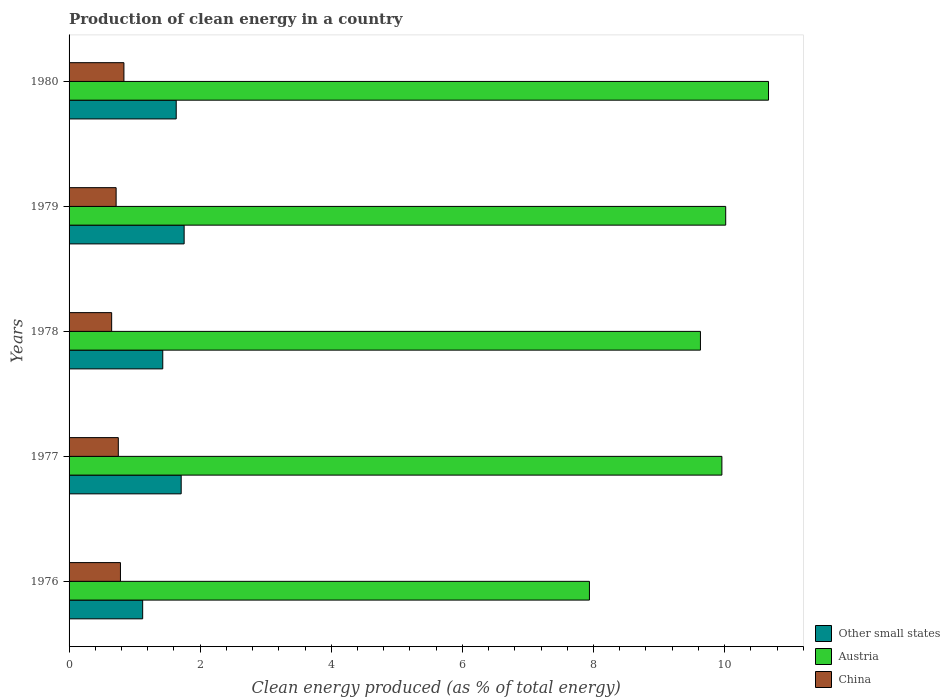How many different coloured bars are there?
Your answer should be very brief. 3. How many groups of bars are there?
Offer a terse response. 5. What is the label of the 1st group of bars from the top?
Ensure brevity in your answer.  1980. What is the percentage of clean energy produced in Other small states in 1977?
Make the answer very short. 1.71. Across all years, what is the maximum percentage of clean energy produced in Austria?
Make the answer very short. 10.67. Across all years, what is the minimum percentage of clean energy produced in China?
Your answer should be very brief. 0.65. In which year was the percentage of clean energy produced in Other small states minimum?
Make the answer very short. 1976. What is the total percentage of clean energy produced in Austria in the graph?
Give a very brief answer. 48.21. What is the difference between the percentage of clean energy produced in China in 1976 and that in 1980?
Make the answer very short. -0.05. What is the difference between the percentage of clean energy produced in Austria in 1980 and the percentage of clean energy produced in China in 1979?
Your answer should be compact. 9.95. What is the average percentage of clean energy produced in China per year?
Provide a succinct answer. 0.75. In the year 1977, what is the difference between the percentage of clean energy produced in Other small states and percentage of clean energy produced in Austria?
Offer a very short reply. -8.25. In how many years, is the percentage of clean energy produced in Austria greater than 4.4 %?
Ensure brevity in your answer.  5. What is the ratio of the percentage of clean energy produced in Other small states in 1979 to that in 1980?
Ensure brevity in your answer.  1.07. Is the percentage of clean energy produced in Austria in 1978 less than that in 1980?
Offer a very short reply. Yes. What is the difference between the highest and the second highest percentage of clean energy produced in China?
Provide a succinct answer. 0.05. What is the difference between the highest and the lowest percentage of clean energy produced in Other small states?
Give a very brief answer. 0.63. What does the 1st bar from the top in 1978 represents?
Provide a short and direct response. China. What does the 1st bar from the bottom in 1979 represents?
Offer a terse response. Other small states. Is it the case that in every year, the sum of the percentage of clean energy produced in China and percentage of clean energy produced in Austria is greater than the percentage of clean energy produced in Other small states?
Ensure brevity in your answer.  Yes. How many years are there in the graph?
Provide a short and direct response. 5. What is the difference between two consecutive major ticks on the X-axis?
Your answer should be very brief. 2. Does the graph contain grids?
Ensure brevity in your answer.  No. Where does the legend appear in the graph?
Your response must be concise. Bottom right. How many legend labels are there?
Ensure brevity in your answer.  3. How are the legend labels stacked?
Your answer should be very brief. Vertical. What is the title of the graph?
Keep it short and to the point. Production of clean energy in a country. What is the label or title of the X-axis?
Offer a terse response. Clean energy produced (as % of total energy). What is the Clean energy produced (as % of total energy) of Other small states in 1976?
Give a very brief answer. 1.12. What is the Clean energy produced (as % of total energy) in Austria in 1976?
Provide a short and direct response. 7.94. What is the Clean energy produced (as % of total energy) of China in 1976?
Provide a short and direct response. 0.78. What is the Clean energy produced (as % of total energy) of Other small states in 1977?
Give a very brief answer. 1.71. What is the Clean energy produced (as % of total energy) of Austria in 1977?
Your answer should be compact. 9.96. What is the Clean energy produced (as % of total energy) of China in 1977?
Your answer should be compact. 0.75. What is the Clean energy produced (as % of total energy) of Other small states in 1978?
Keep it short and to the point. 1.43. What is the Clean energy produced (as % of total energy) of Austria in 1978?
Your response must be concise. 9.63. What is the Clean energy produced (as % of total energy) in China in 1978?
Keep it short and to the point. 0.65. What is the Clean energy produced (as % of total energy) in Other small states in 1979?
Your response must be concise. 1.76. What is the Clean energy produced (as % of total energy) of Austria in 1979?
Offer a very short reply. 10.02. What is the Clean energy produced (as % of total energy) in China in 1979?
Provide a short and direct response. 0.72. What is the Clean energy produced (as % of total energy) of Other small states in 1980?
Offer a very short reply. 1.63. What is the Clean energy produced (as % of total energy) of Austria in 1980?
Your response must be concise. 10.67. What is the Clean energy produced (as % of total energy) of China in 1980?
Your response must be concise. 0.84. Across all years, what is the maximum Clean energy produced (as % of total energy) of Other small states?
Offer a terse response. 1.76. Across all years, what is the maximum Clean energy produced (as % of total energy) in Austria?
Your response must be concise. 10.67. Across all years, what is the maximum Clean energy produced (as % of total energy) in China?
Your answer should be compact. 0.84. Across all years, what is the minimum Clean energy produced (as % of total energy) in Other small states?
Your response must be concise. 1.12. Across all years, what is the minimum Clean energy produced (as % of total energy) of Austria?
Your answer should be very brief. 7.94. Across all years, what is the minimum Clean energy produced (as % of total energy) of China?
Your answer should be very brief. 0.65. What is the total Clean energy produced (as % of total energy) in Other small states in the graph?
Give a very brief answer. 7.65. What is the total Clean energy produced (as % of total energy) of Austria in the graph?
Give a very brief answer. 48.21. What is the total Clean energy produced (as % of total energy) of China in the graph?
Your answer should be compact. 3.74. What is the difference between the Clean energy produced (as % of total energy) in Other small states in 1976 and that in 1977?
Your answer should be compact. -0.59. What is the difference between the Clean energy produced (as % of total energy) in Austria in 1976 and that in 1977?
Ensure brevity in your answer.  -2.02. What is the difference between the Clean energy produced (as % of total energy) in China in 1976 and that in 1977?
Your answer should be compact. 0.03. What is the difference between the Clean energy produced (as % of total energy) of Other small states in 1976 and that in 1978?
Ensure brevity in your answer.  -0.31. What is the difference between the Clean energy produced (as % of total energy) in Austria in 1976 and that in 1978?
Give a very brief answer. -1.69. What is the difference between the Clean energy produced (as % of total energy) of China in 1976 and that in 1978?
Offer a terse response. 0.13. What is the difference between the Clean energy produced (as % of total energy) in Other small states in 1976 and that in 1979?
Give a very brief answer. -0.63. What is the difference between the Clean energy produced (as % of total energy) of Austria in 1976 and that in 1979?
Your answer should be very brief. -2.08. What is the difference between the Clean energy produced (as % of total energy) of China in 1976 and that in 1979?
Provide a short and direct response. 0.07. What is the difference between the Clean energy produced (as % of total energy) in Other small states in 1976 and that in 1980?
Offer a very short reply. -0.51. What is the difference between the Clean energy produced (as % of total energy) in Austria in 1976 and that in 1980?
Make the answer very short. -2.73. What is the difference between the Clean energy produced (as % of total energy) in China in 1976 and that in 1980?
Ensure brevity in your answer.  -0.05. What is the difference between the Clean energy produced (as % of total energy) in Other small states in 1977 and that in 1978?
Give a very brief answer. 0.28. What is the difference between the Clean energy produced (as % of total energy) in Austria in 1977 and that in 1978?
Your response must be concise. 0.33. What is the difference between the Clean energy produced (as % of total energy) of China in 1977 and that in 1978?
Give a very brief answer. 0.1. What is the difference between the Clean energy produced (as % of total energy) in Other small states in 1977 and that in 1979?
Offer a very short reply. -0.04. What is the difference between the Clean energy produced (as % of total energy) of Austria in 1977 and that in 1979?
Ensure brevity in your answer.  -0.06. What is the difference between the Clean energy produced (as % of total energy) in China in 1977 and that in 1979?
Ensure brevity in your answer.  0.03. What is the difference between the Clean energy produced (as % of total energy) of Other small states in 1977 and that in 1980?
Offer a terse response. 0.08. What is the difference between the Clean energy produced (as % of total energy) of Austria in 1977 and that in 1980?
Give a very brief answer. -0.71. What is the difference between the Clean energy produced (as % of total energy) in China in 1977 and that in 1980?
Your answer should be compact. -0.09. What is the difference between the Clean energy produced (as % of total energy) in Other small states in 1978 and that in 1979?
Provide a short and direct response. -0.33. What is the difference between the Clean energy produced (as % of total energy) of Austria in 1978 and that in 1979?
Give a very brief answer. -0.39. What is the difference between the Clean energy produced (as % of total energy) in China in 1978 and that in 1979?
Offer a terse response. -0.07. What is the difference between the Clean energy produced (as % of total energy) in Other small states in 1978 and that in 1980?
Offer a terse response. -0.21. What is the difference between the Clean energy produced (as % of total energy) in Austria in 1978 and that in 1980?
Give a very brief answer. -1.04. What is the difference between the Clean energy produced (as % of total energy) in China in 1978 and that in 1980?
Your answer should be compact. -0.19. What is the difference between the Clean energy produced (as % of total energy) of Other small states in 1979 and that in 1980?
Provide a succinct answer. 0.12. What is the difference between the Clean energy produced (as % of total energy) in Austria in 1979 and that in 1980?
Provide a succinct answer. -0.65. What is the difference between the Clean energy produced (as % of total energy) in China in 1979 and that in 1980?
Provide a short and direct response. -0.12. What is the difference between the Clean energy produced (as % of total energy) of Other small states in 1976 and the Clean energy produced (as % of total energy) of Austria in 1977?
Ensure brevity in your answer.  -8.84. What is the difference between the Clean energy produced (as % of total energy) of Other small states in 1976 and the Clean energy produced (as % of total energy) of China in 1977?
Your response must be concise. 0.37. What is the difference between the Clean energy produced (as % of total energy) of Austria in 1976 and the Clean energy produced (as % of total energy) of China in 1977?
Ensure brevity in your answer.  7.19. What is the difference between the Clean energy produced (as % of total energy) of Other small states in 1976 and the Clean energy produced (as % of total energy) of Austria in 1978?
Offer a terse response. -8.51. What is the difference between the Clean energy produced (as % of total energy) in Other small states in 1976 and the Clean energy produced (as % of total energy) in China in 1978?
Your answer should be compact. 0.47. What is the difference between the Clean energy produced (as % of total energy) in Austria in 1976 and the Clean energy produced (as % of total energy) in China in 1978?
Your answer should be very brief. 7.29. What is the difference between the Clean energy produced (as % of total energy) of Other small states in 1976 and the Clean energy produced (as % of total energy) of Austria in 1979?
Provide a succinct answer. -8.89. What is the difference between the Clean energy produced (as % of total energy) in Other small states in 1976 and the Clean energy produced (as % of total energy) in China in 1979?
Provide a succinct answer. 0.4. What is the difference between the Clean energy produced (as % of total energy) of Austria in 1976 and the Clean energy produced (as % of total energy) of China in 1979?
Ensure brevity in your answer.  7.22. What is the difference between the Clean energy produced (as % of total energy) in Other small states in 1976 and the Clean energy produced (as % of total energy) in Austria in 1980?
Keep it short and to the point. -9.55. What is the difference between the Clean energy produced (as % of total energy) in Other small states in 1976 and the Clean energy produced (as % of total energy) in China in 1980?
Give a very brief answer. 0.29. What is the difference between the Clean energy produced (as % of total energy) in Austria in 1976 and the Clean energy produced (as % of total energy) in China in 1980?
Keep it short and to the point. 7.1. What is the difference between the Clean energy produced (as % of total energy) in Other small states in 1977 and the Clean energy produced (as % of total energy) in Austria in 1978?
Provide a succinct answer. -7.92. What is the difference between the Clean energy produced (as % of total energy) of Other small states in 1977 and the Clean energy produced (as % of total energy) of China in 1978?
Provide a succinct answer. 1.06. What is the difference between the Clean energy produced (as % of total energy) in Austria in 1977 and the Clean energy produced (as % of total energy) in China in 1978?
Ensure brevity in your answer.  9.31. What is the difference between the Clean energy produced (as % of total energy) in Other small states in 1977 and the Clean energy produced (as % of total energy) in Austria in 1979?
Offer a very short reply. -8.31. What is the difference between the Clean energy produced (as % of total energy) in Austria in 1977 and the Clean energy produced (as % of total energy) in China in 1979?
Offer a terse response. 9.24. What is the difference between the Clean energy produced (as % of total energy) of Other small states in 1977 and the Clean energy produced (as % of total energy) of Austria in 1980?
Your answer should be very brief. -8.96. What is the difference between the Clean energy produced (as % of total energy) in Other small states in 1977 and the Clean energy produced (as % of total energy) in China in 1980?
Keep it short and to the point. 0.87. What is the difference between the Clean energy produced (as % of total energy) of Austria in 1977 and the Clean energy produced (as % of total energy) of China in 1980?
Keep it short and to the point. 9.12. What is the difference between the Clean energy produced (as % of total energy) in Other small states in 1978 and the Clean energy produced (as % of total energy) in Austria in 1979?
Provide a succinct answer. -8.59. What is the difference between the Clean energy produced (as % of total energy) in Other small states in 1978 and the Clean energy produced (as % of total energy) in China in 1979?
Make the answer very short. 0.71. What is the difference between the Clean energy produced (as % of total energy) in Austria in 1978 and the Clean energy produced (as % of total energy) in China in 1979?
Your answer should be compact. 8.91. What is the difference between the Clean energy produced (as % of total energy) of Other small states in 1978 and the Clean energy produced (as % of total energy) of Austria in 1980?
Provide a succinct answer. -9.24. What is the difference between the Clean energy produced (as % of total energy) in Other small states in 1978 and the Clean energy produced (as % of total energy) in China in 1980?
Give a very brief answer. 0.59. What is the difference between the Clean energy produced (as % of total energy) of Austria in 1978 and the Clean energy produced (as % of total energy) of China in 1980?
Give a very brief answer. 8.79. What is the difference between the Clean energy produced (as % of total energy) in Other small states in 1979 and the Clean energy produced (as % of total energy) in Austria in 1980?
Keep it short and to the point. -8.91. What is the difference between the Clean energy produced (as % of total energy) of Other small states in 1979 and the Clean energy produced (as % of total energy) of China in 1980?
Provide a short and direct response. 0.92. What is the difference between the Clean energy produced (as % of total energy) in Austria in 1979 and the Clean energy produced (as % of total energy) in China in 1980?
Your answer should be very brief. 9.18. What is the average Clean energy produced (as % of total energy) of Other small states per year?
Provide a short and direct response. 1.53. What is the average Clean energy produced (as % of total energy) of Austria per year?
Provide a short and direct response. 9.64. What is the average Clean energy produced (as % of total energy) of China per year?
Offer a very short reply. 0.75. In the year 1976, what is the difference between the Clean energy produced (as % of total energy) of Other small states and Clean energy produced (as % of total energy) of Austria?
Ensure brevity in your answer.  -6.81. In the year 1976, what is the difference between the Clean energy produced (as % of total energy) of Other small states and Clean energy produced (as % of total energy) of China?
Make the answer very short. 0.34. In the year 1976, what is the difference between the Clean energy produced (as % of total energy) in Austria and Clean energy produced (as % of total energy) in China?
Provide a succinct answer. 7.15. In the year 1977, what is the difference between the Clean energy produced (as % of total energy) of Other small states and Clean energy produced (as % of total energy) of Austria?
Keep it short and to the point. -8.25. In the year 1977, what is the difference between the Clean energy produced (as % of total energy) in Other small states and Clean energy produced (as % of total energy) in China?
Your answer should be very brief. 0.96. In the year 1977, what is the difference between the Clean energy produced (as % of total energy) of Austria and Clean energy produced (as % of total energy) of China?
Make the answer very short. 9.21. In the year 1978, what is the difference between the Clean energy produced (as % of total energy) in Other small states and Clean energy produced (as % of total energy) in Austria?
Ensure brevity in your answer.  -8.2. In the year 1978, what is the difference between the Clean energy produced (as % of total energy) in Other small states and Clean energy produced (as % of total energy) in China?
Your answer should be compact. 0.78. In the year 1978, what is the difference between the Clean energy produced (as % of total energy) of Austria and Clean energy produced (as % of total energy) of China?
Ensure brevity in your answer.  8.98. In the year 1979, what is the difference between the Clean energy produced (as % of total energy) in Other small states and Clean energy produced (as % of total energy) in Austria?
Ensure brevity in your answer.  -8.26. In the year 1979, what is the difference between the Clean energy produced (as % of total energy) in Other small states and Clean energy produced (as % of total energy) in China?
Make the answer very short. 1.04. In the year 1979, what is the difference between the Clean energy produced (as % of total energy) of Austria and Clean energy produced (as % of total energy) of China?
Your answer should be compact. 9.3. In the year 1980, what is the difference between the Clean energy produced (as % of total energy) in Other small states and Clean energy produced (as % of total energy) in Austria?
Your response must be concise. -9.03. In the year 1980, what is the difference between the Clean energy produced (as % of total energy) of Other small states and Clean energy produced (as % of total energy) of China?
Ensure brevity in your answer.  0.8. In the year 1980, what is the difference between the Clean energy produced (as % of total energy) of Austria and Clean energy produced (as % of total energy) of China?
Give a very brief answer. 9.83. What is the ratio of the Clean energy produced (as % of total energy) in Other small states in 1976 to that in 1977?
Offer a terse response. 0.66. What is the ratio of the Clean energy produced (as % of total energy) of Austria in 1976 to that in 1977?
Keep it short and to the point. 0.8. What is the ratio of the Clean energy produced (as % of total energy) of China in 1976 to that in 1977?
Give a very brief answer. 1.04. What is the ratio of the Clean energy produced (as % of total energy) of Other small states in 1976 to that in 1978?
Ensure brevity in your answer.  0.79. What is the ratio of the Clean energy produced (as % of total energy) of Austria in 1976 to that in 1978?
Ensure brevity in your answer.  0.82. What is the ratio of the Clean energy produced (as % of total energy) in China in 1976 to that in 1978?
Offer a very short reply. 1.21. What is the ratio of the Clean energy produced (as % of total energy) in Other small states in 1976 to that in 1979?
Keep it short and to the point. 0.64. What is the ratio of the Clean energy produced (as % of total energy) of Austria in 1976 to that in 1979?
Offer a terse response. 0.79. What is the ratio of the Clean energy produced (as % of total energy) of China in 1976 to that in 1979?
Your answer should be very brief. 1.09. What is the ratio of the Clean energy produced (as % of total energy) in Other small states in 1976 to that in 1980?
Your response must be concise. 0.69. What is the ratio of the Clean energy produced (as % of total energy) in Austria in 1976 to that in 1980?
Ensure brevity in your answer.  0.74. What is the ratio of the Clean energy produced (as % of total energy) in China in 1976 to that in 1980?
Your answer should be compact. 0.94. What is the ratio of the Clean energy produced (as % of total energy) in Other small states in 1977 to that in 1978?
Ensure brevity in your answer.  1.2. What is the ratio of the Clean energy produced (as % of total energy) of Austria in 1977 to that in 1978?
Provide a short and direct response. 1.03. What is the ratio of the Clean energy produced (as % of total energy) in China in 1977 to that in 1978?
Offer a very short reply. 1.16. What is the ratio of the Clean energy produced (as % of total energy) of Other small states in 1977 to that in 1979?
Your response must be concise. 0.97. What is the ratio of the Clean energy produced (as % of total energy) of China in 1977 to that in 1979?
Your answer should be very brief. 1.05. What is the ratio of the Clean energy produced (as % of total energy) of Other small states in 1977 to that in 1980?
Provide a succinct answer. 1.05. What is the ratio of the Clean energy produced (as % of total energy) in China in 1977 to that in 1980?
Ensure brevity in your answer.  0.9. What is the ratio of the Clean energy produced (as % of total energy) in Other small states in 1978 to that in 1979?
Provide a succinct answer. 0.81. What is the ratio of the Clean energy produced (as % of total energy) in Austria in 1978 to that in 1979?
Offer a very short reply. 0.96. What is the ratio of the Clean energy produced (as % of total energy) of China in 1978 to that in 1979?
Provide a succinct answer. 0.91. What is the ratio of the Clean energy produced (as % of total energy) in Other small states in 1978 to that in 1980?
Keep it short and to the point. 0.87. What is the ratio of the Clean energy produced (as % of total energy) in Austria in 1978 to that in 1980?
Ensure brevity in your answer.  0.9. What is the ratio of the Clean energy produced (as % of total energy) of China in 1978 to that in 1980?
Offer a terse response. 0.78. What is the ratio of the Clean energy produced (as % of total energy) in Other small states in 1979 to that in 1980?
Provide a short and direct response. 1.07. What is the ratio of the Clean energy produced (as % of total energy) in Austria in 1979 to that in 1980?
Make the answer very short. 0.94. What is the ratio of the Clean energy produced (as % of total energy) in China in 1979 to that in 1980?
Keep it short and to the point. 0.86. What is the difference between the highest and the second highest Clean energy produced (as % of total energy) in Other small states?
Provide a short and direct response. 0.04. What is the difference between the highest and the second highest Clean energy produced (as % of total energy) in Austria?
Offer a very short reply. 0.65. What is the difference between the highest and the second highest Clean energy produced (as % of total energy) in China?
Keep it short and to the point. 0.05. What is the difference between the highest and the lowest Clean energy produced (as % of total energy) in Other small states?
Ensure brevity in your answer.  0.63. What is the difference between the highest and the lowest Clean energy produced (as % of total energy) of Austria?
Make the answer very short. 2.73. What is the difference between the highest and the lowest Clean energy produced (as % of total energy) in China?
Offer a terse response. 0.19. 